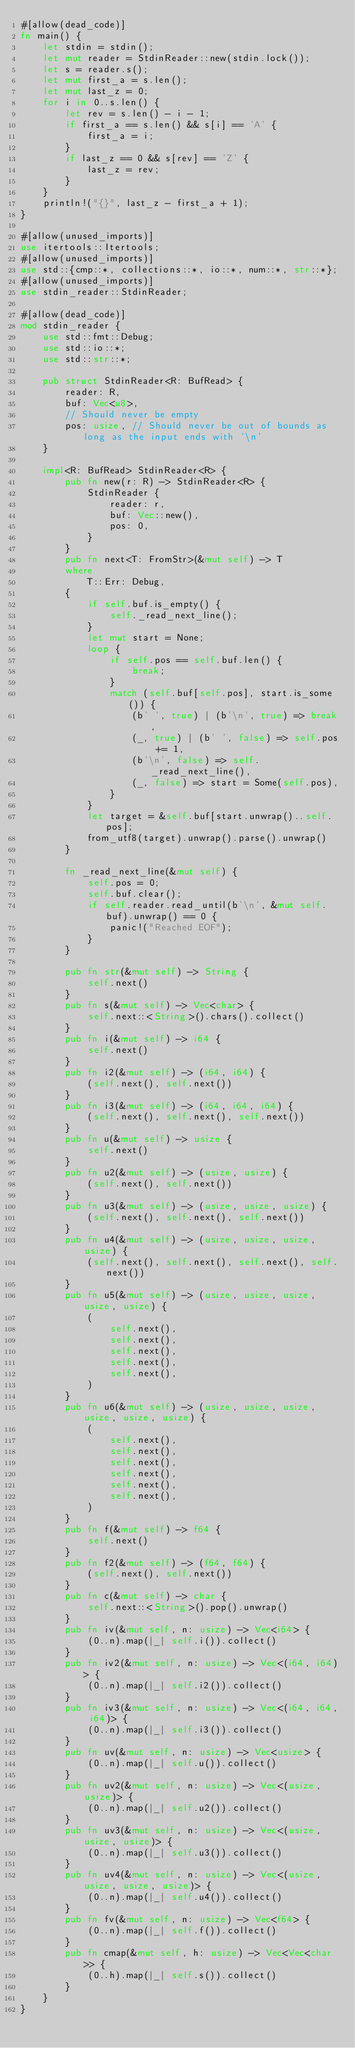Convert code to text. <code><loc_0><loc_0><loc_500><loc_500><_Rust_>#[allow(dead_code)]
fn main() {
    let stdin = stdin();
    let mut reader = StdinReader::new(stdin.lock());
    let s = reader.s();
    let mut first_a = s.len();
    let mut last_z = 0;
    for i in 0..s.len() {
        let rev = s.len() - i - 1;
        if first_a == s.len() && s[i] == 'A' {
            first_a = i;
        }
        if last_z == 0 && s[rev] == 'Z' {
            last_z = rev;
        }
    }
    println!("{}", last_z - first_a + 1);
}

#[allow(unused_imports)]
use itertools::Itertools;
#[allow(unused_imports)]
use std::{cmp::*, collections::*, io::*, num::*, str::*};
#[allow(unused_imports)]
use stdin_reader::StdinReader;

#[allow(dead_code)]
mod stdin_reader {
    use std::fmt::Debug;
    use std::io::*;
    use std::str::*;

    pub struct StdinReader<R: BufRead> {
        reader: R,
        buf: Vec<u8>,
        // Should never be empty
        pos: usize, // Should never be out of bounds as long as the input ends with '\n'
    }

    impl<R: BufRead> StdinReader<R> {
        pub fn new(r: R) -> StdinReader<R> {
            StdinReader {
                reader: r,
                buf: Vec::new(),
                pos: 0,
            }
        }
        pub fn next<T: FromStr>(&mut self) -> T
        where
            T::Err: Debug,
        {
            if self.buf.is_empty() {
                self._read_next_line();
            }
            let mut start = None;
            loop {
                if self.pos == self.buf.len() {
                    break;
                }
                match (self.buf[self.pos], start.is_some()) {
                    (b' ', true) | (b'\n', true) => break,
                    (_, true) | (b' ', false) => self.pos += 1,
                    (b'\n', false) => self._read_next_line(),
                    (_, false) => start = Some(self.pos),
                }
            }
            let target = &self.buf[start.unwrap()..self.pos];
            from_utf8(target).unwrap().parse().unwrap()
        }

        fn _read_next_line(&mut self) {
            self.pos = 0;
            self.buf.clear();
            if self.reader.read_until(b'\n', &mut self.buf).unwrap() == 0 {
                panic!("Reached EOF");
            }
        }

        pub fn str(&mut self) -> String {
            self.next()
        }
        pub fn s(&mut self) -> Vec<char> {
            self.next::<String>().chars().collect()
        }
        pub fn i(&mut self) -> i64 {
            self.next()
        }
        pub fn i2(&mut self) -> (i64, i64) {
            (self.next(), self.next())
        }
        pub fn i3(&mut self) -> (i64, i64, i64) {
            (self.next(), self.next(), self.next())
        }
        pub fn u(&mut self) -> usize {
            self.next()
        }
        pub fn u2(&mut self) -> (usize, usize) {
            (self.next(), self.next())
        }
        pub fn u3(&mut self) -> (usize, usize, usize) {
            (self.next(), self.next(), self.next())
        }
        pub fn u4(&mut self) -> (usize, usize, usize, usize) {
            (self.next(), self.next(), self.next(), self.next())
        }
        pub fn u5(&mut self) -> (usize, usize, usize, usize, usize) {
            (
                self.next(),
                self.next(),
                self.next(),
                self.next(),
                self.next(),
            )
        }
        pub fn u6(&mut self) -> (usize, usize, usize, usize, usize, usize) {
            (
                self.next(),
                self.next(),
                self.next(),
                self.next(),
                self.next(),
                self.next(),
            )
        }
        pub fn f(&mut self) -> f64 {
            self.next()
        }
        pub fn f2(&mut self) -> (f64, f64) {
            (self.next(), self.next())
        }
        pub fn c(&mut self) -> char {
            self.next::<String>().pop().unwrap()
        }
        pub fn iv(&mut self, n: usize) -> Vec<i64> {
            (0..n).map(|_| self.i()).collect()
        }
        pub fn iv2(&mut self, n: usize) -> Vec<(i64, i64)> {
            (0..n).map(|_| self.i2()).collect()
        }
        pub fn iv3(&mut self, n: usize) -> Vec<(i64, i64, i64)> {
            (0..n).map(|_| self.i3()).collect()
        }
        pub fn uv(&mut self, n: usize) -> Vec<usize> {
            (0..n).map(|_| self.u()).collect()
        }
        pub fn uv2(&mut self, n: usize) -> Vec<(usize, usize)> {
            (0..n).map(|_| self.u2()).collect()
        }
        pub fn uv3(&mut self, n: usize) -> Vec<(usize, usize, usize)> {
            (0..n).map(|_| self.u3()).collect()
        }
        pub fn uv4(&mut self, n: usize) -> Vec<(usize, usize, usize, usize)> {
            (0..n).map(|_| self.u4()).collect()
        }
        pub fn fv(&mut self, n: usize) -> Vec<f64> {
            (0..n).map(|_| self.f()).collect()
        }
        pub fn cmap(&mut self, h: usize) -> Vec<Vec<char>> {
            (0..h).map(|_| self.s()).collect()
        }
    }
}
</code> 